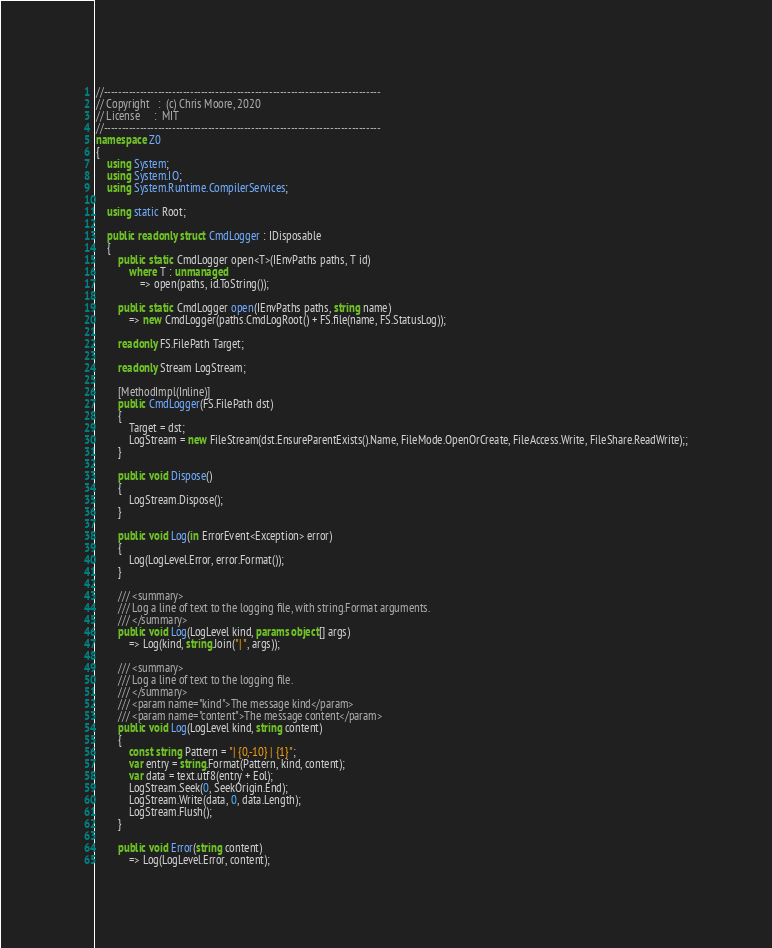Convert code to text. <code><loc_0><loc_0><loc_500><loc_500><_C#_>//-----------------------------------------------------------------------------
// Copyright   :  (c) Chris Moore, 2020
// License     :  MIT
//-----------------------------------------------------------------------------
namespace Z0
{
    using System;
    using System.IO;
    using System.Runtime.CompilerServices;

    using static Root;

    public readonly struct CmdLogger : IDisposable
    {
        public static CmdLogger open<T>(IEnvPaths paths, T id)
            where T : unmanaged
                => open(paths, id.ToString());

        public static CmdLogger open(IEnvPaths paths, string name)
            => new CmdLogger(paths.CmdLogRoot() + FS.file(name, FS.StatusLog));

        readonly FS.FilePath Target;

        readonly Stream LogStream;

        [MethodImpl(Inline)]
        public CmdLogger(FS.FilePath dst)
        {
            Target = dst;
            LogStream = new FileStream(dst.EnsureParentExists().Name, FileMode.OpenOrCreate, FileAccess.Write, FileShare.ReadWrite);;
        }

        public void Dispose()
        {
            LogStream.Dispose();
        }

        public void Log(in ErrorEvent<Exception> error)
        {
            Log(LogLevel.Error, error.Format());
        }

        /// <summary>
        /// Log a line of text to the logging file, with string.Format arguments.
        /// </summary>
        public void Log(LogLevel kind, params object[] args)
            => Log(kind, string.Join("| ", args));

        /// <summary>
        /// Log a line of text to the logging file.
        /// </summary>
        /// <param name="kind">The message kind</param>
        /// <param name="content">The message content</param>
        public void Log(LogLevel kind, string content)
        {
            const string Pattern = "| {0,-10} | {1}";
            var entry = string.Format(Pattern, kind, content);
            var data = text.utf8(entry + Eol);
            LogStream.Seek(0, SeekOrigin.End);
            LogStream.Write(data, 0, data.Length);
            LogStream.Flush();
        }

        public void Error(string content)
            => Log(LogLevel.Error, content);
</code> 